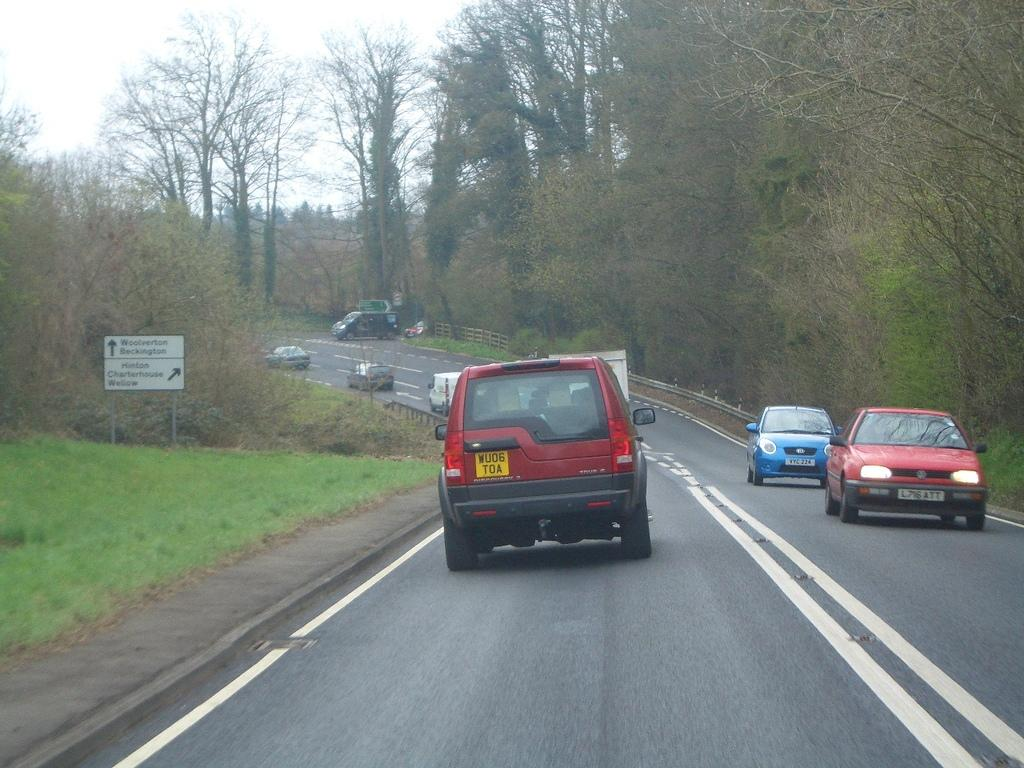What is the main feature of the image? There is a road in the image. What can be seen on the road? There are colorful vehicles on the road. What is located to the left of the image? There is a board to the left of the image. What type of natural environment is visible in the background? There are many trees in the background of the image. What is the color of the sky in the background? The sky is white in the background of the image. How does the rainstorm affect the vehicles on the road in the image? There is no rainstorm present in the image; the sky is white, and the vehicles are colorful and visible on the road. 